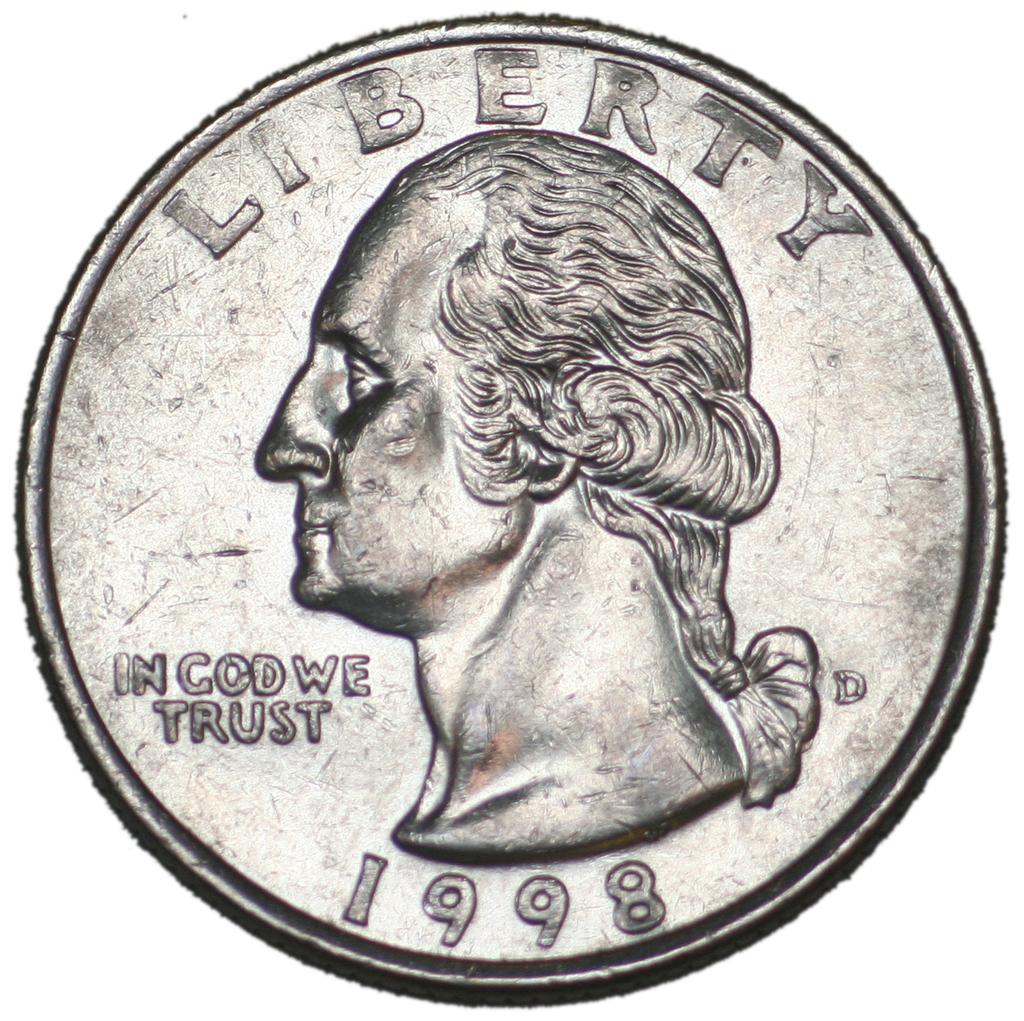What year is this quarter?
Keep it short and to the point. 1998. What word is at the top of the coin?
Your answer should be compact. Liberty. 